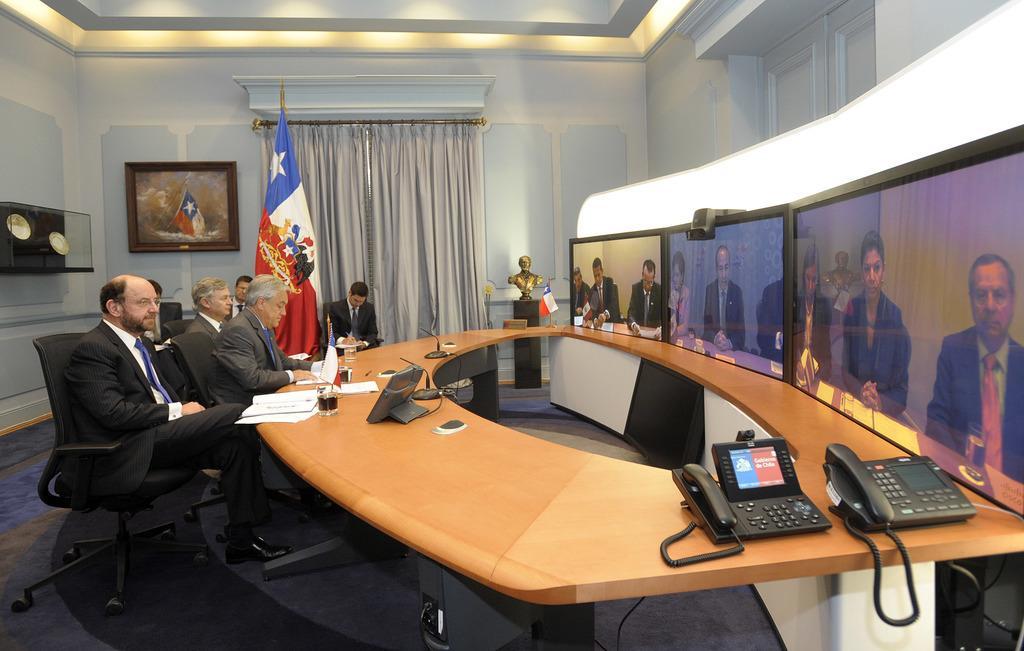Could you give a brief overview of what you see in this image? There are some people sitting in the chairs in front of a table on which a screen, glass some papers and two telephones were placed. There are three TVs attached to the wall. In the background there is a flag curtain and a photo frame attached to the wall. 